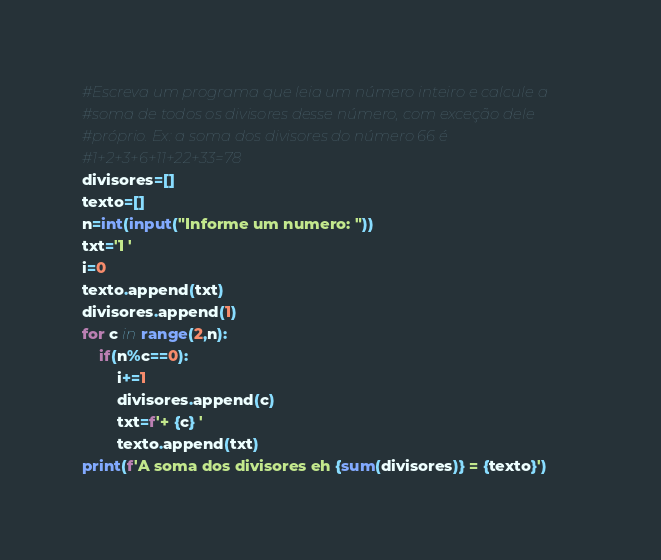Convert code to text. <code><loc_0><loc_0><loc_500><loc_500><_Python_>#Escreva um programa que leia um número inteiro e calcule a
#soma de todos os divisores desse número, com exceção dele
#próprio. Ex: a soma dos divisores do número 66 é
#1+2+3+6+11+22+33=78
divisores=[]
texto=[]
n=int(input("Informe um numero: "))
txt='1 '
i=0
texto.append(txt)
divisores.append(1)
for c in range(2,n):
    if(n%c==0):
        i+=1
        divisores.append(c)
        txt=f'+ {c} '
        texto.append(txt)
print(f'A soma dos divisores eh {sum(divisores)} = {texto}')</code> 